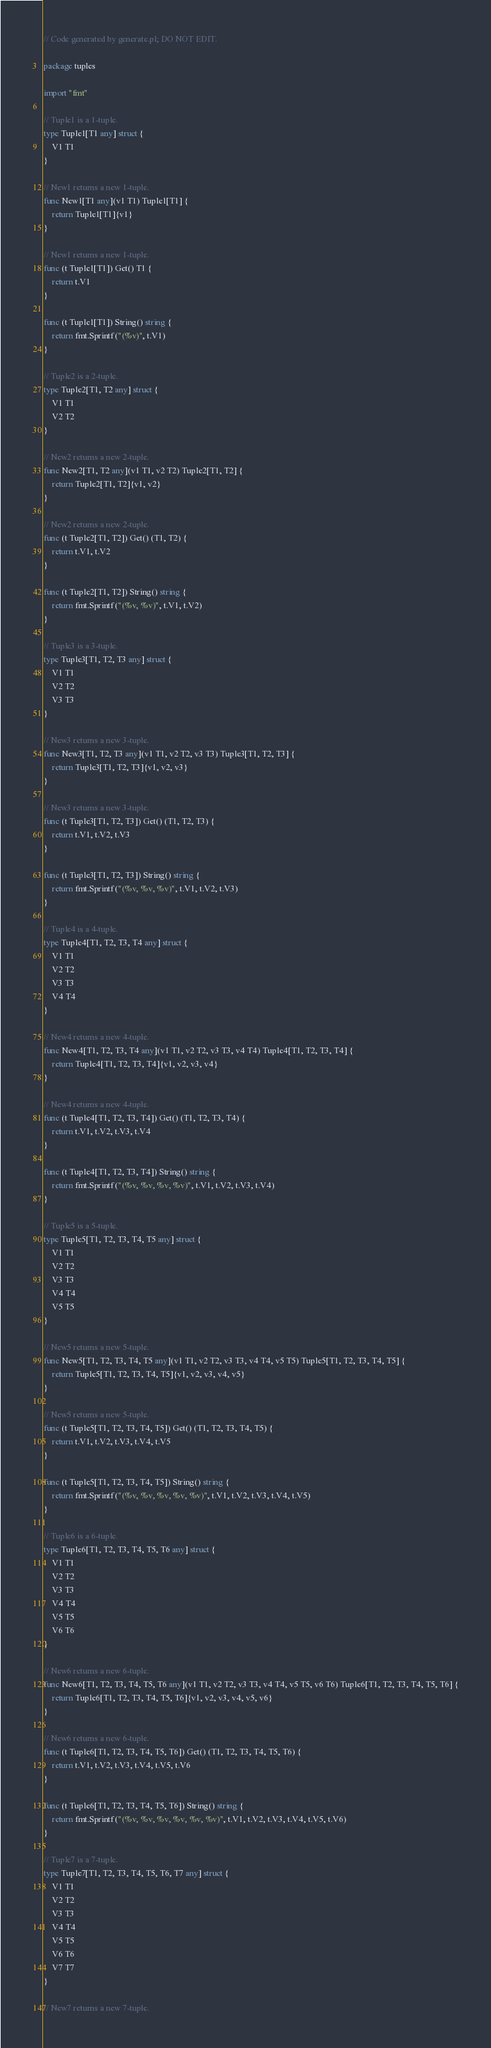Convert code to text. <code><loc_0><loc_0><loc_500><loc_500><_Go_>// Code generated by generate.pl; DO NOT EDIT.

package tuples

import "fmt"

// Tuple1 is a 1-tuple.
type Tuple1[T1 any] struct {
	V1 T1
}

// New1 returns a new 1-tuple.
func New1[T1 any](v1 T1) Tuple1[T1] {
	return Tuple1[T1]{v1}
}

// New1 returns a new 1-tuple.
func (t Tuple1[T1]) Get() T1 {
	return t.V1
}

func (t Tuple1[T1]) String() string {
	return fmt.Sprintf("(%v)", t.V1)
}

// Tuple2 is a 2-tuple.
type Tuple2[T1, T2 any] struct {
	V1 T1
	V2 T2
}

// New2 returns a new 2-tuple.
func New2[T1, T2 any](v1 T1, v2 T2) Tuple2[T1, T2] {
	return Tuple2[T1, T2]{v1, v2}
}

// New2 returns a new 2-tuple.
func (t Tuple2[T1, T2]) Get() (T1, T2) {
	return t.V1, t.V2
}

func (t Tuple2[T1, T2]) String() string {
	return fmt.Sprintf("(%v, %v)", t.V1, t.V2)
}

// Tuple3 is a 3-tuple.
type Tuple3[T1, T2, T3 any] struct {
	V1 T1
	V2 T2
	V3 T3
}

// New3 returns a new 3-tuple.
func New3[T1, T2, T3 any](v1 T1, v2 T2, v3 T3) Tuple3[T1, T2, T3] {
	return Tuple3[T1, T2, T3]{v1, v2, v3}
}

// New3 returns a new 3-tuple.
func (t Tuple3[T1, T2, T3]) Get() (T1, T2, T3) {
	return t.V1, t.V2, t.V3
}

func (t Tuple3[T1, T2, T3]) String() string {
	return fmt.Sprintf("(%v, %v, %v)", t.V1, t.V2, t.V3)
}

// Tuple4 is a 4-tuple.
type Tuple4[T1, T2, T3, T4 any] struct {
	V1 T1
	V2 T2
	V3 T3
	V4 T4
}

// New4 returns a new 4-tuple.
func New4[T1, T2, T3, T4 any](v1 T1, v2 T2, v3 T3, v4 T4) Tuple4[T1, T2, T3, T4] {
	return Tuple4[T1, T2, T3, T4]{v1, v2, v3, v4}
}

// New4 returns a new 4-tuple.
func (t Tuple4[T1, T2, T3, T4]) Get() (T1, T2, T3, T4) {
	return t.V1, t.V2, t.V3, t.V4
}

func (t Tuple4[T1, T2, T3, T4]) String() string {
	return fmt.Sprintf("(%v, %v, %v, %v)", t.V1, t.V2, t.V3, t.V4)
}

// Tuple5 is a 5-tuple.
type Tuple5[T1, T2, T3, T4, T5 any] struct {
	V1 T1
	V2 T2
	V3 T3
	V4 T4
	V5 T5
}

// New5 returns a new 5-tuple.
func New5[T1, T2, T3, T4, T5 any](v1 T1, v2 T2, v3 T3, v4 T4, v5 T5) Tuple5[T1, T2, T3, T4, T5] {
	return Tuple5[T1, T2, T3, T4, T5]{v1, v2, v3, v4, v5}
}

// New5 returns a new 5-tuple.
func (t Tuple5[T1, T2, T3, T4, T5]) Get() (T1, T2, T3, T4, T5) {
	return t.V1, t.V2, t.V3, t.V4, t.V5
}

func (t Tuple5[T1, T2, T3, T4, T5]) String() string {
	return fmt.Sprintf("(%v, %v, %v, %v, %v)", t.V1, t.V2, t.V3, t.V4, t.V5)
}

// Tuple6 is a 6-tuple.
type Tuple6[T1, T2, T3, T4, T5, T6 any] struct {
	V1 T1
	V2 T2
	V3 T3
	V4 T4
	V5 T5
	V6 T6
}

// New6 returns a new 6-tuple.
func New6[T1, T2, T3, T4, T5, T6 any](v1 T1, v2 T2, v3 T3, v4 T4, v5 T5, v6 T6) Tuple6[T1, T2, T3, T4, T5, T6] {
	return Tuple6[T1, T2, T3, T4, T5, T6]{v1, v2, v3, v4, v5, v6}
}

// New6 returns a new 6-tuple.
func (t Tuple6[T1, T2, T3, T4, T5, T6]) Get() (T1, T2, T3, T4, T5, T6) {
	return t.V1, t.V2, t.V3, t.V4, t.V5, t.V6
}

func (t Tuple6[T1, T2, T3, T4, T5, T6]) String() string {
	return fmt.Sprintf("(%v, %v, %v, %v, %v, %v)", t.V1, t.V2, t.V3, t.V4, t.V5, t.V6)
}

// Tuple7 is a 7-tuple.
type Tuple7[T1, T2, T3, T4, T5, T6, T7 any] struct {
	V1 T1
	V2 T2
	V3 T3
	V4 T4
	V5 T5
	V6 T6
	V7 T7
}

// New7 returns a new 7-tuple.</code> 